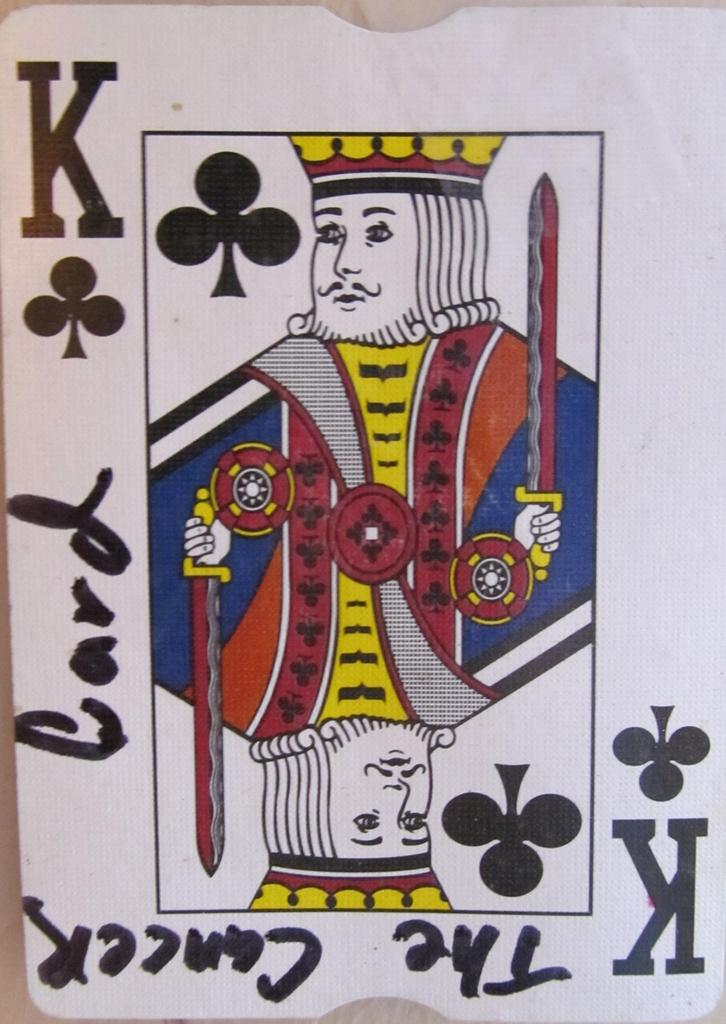<image>
Describe the image concisely. The playing card has black writing of card on the left side. 